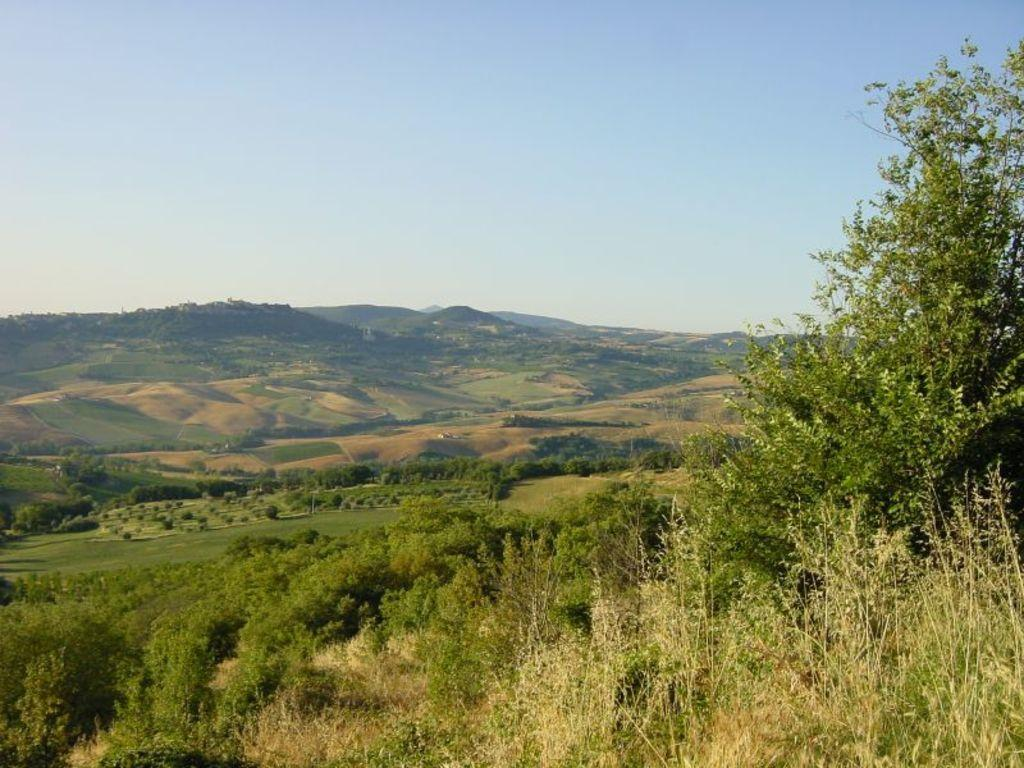What type of vegetation can be seen in the image? There is grass in the image. What is the color of the grass and trees in the image? The grass and trees are green in color. What is visible in the background of the image? There is ground, mountains, and the sky visible in the background of the image. How many kittens are playing on the cable in the image? There is no cable or kittens present in the image. What type of goose can be seen swimming in the grass in the image? There is no goose present in the image, and geese do not swim in grass. 